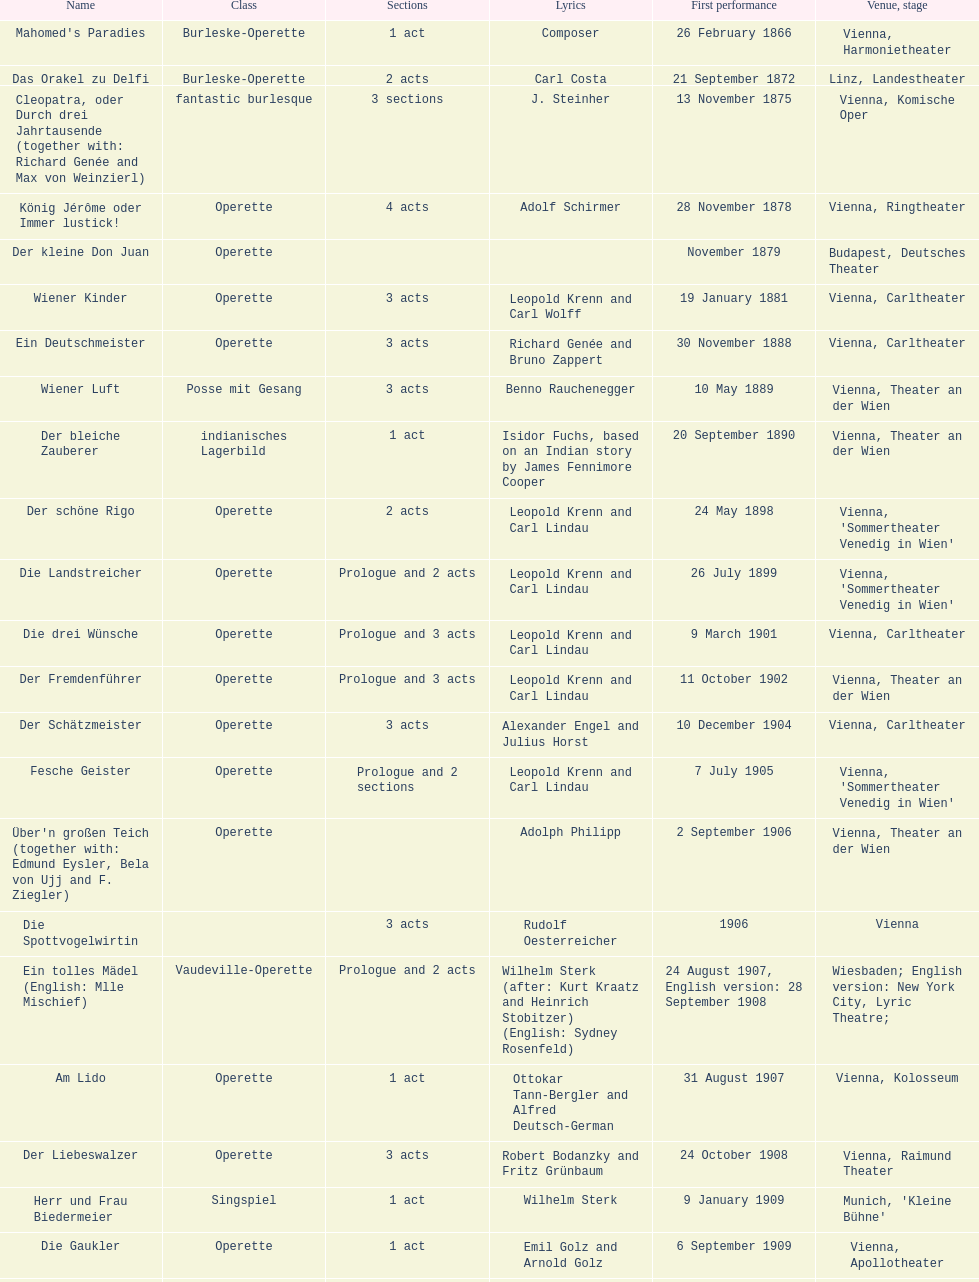What are the number of titles that premiered in the month of september? 4. 